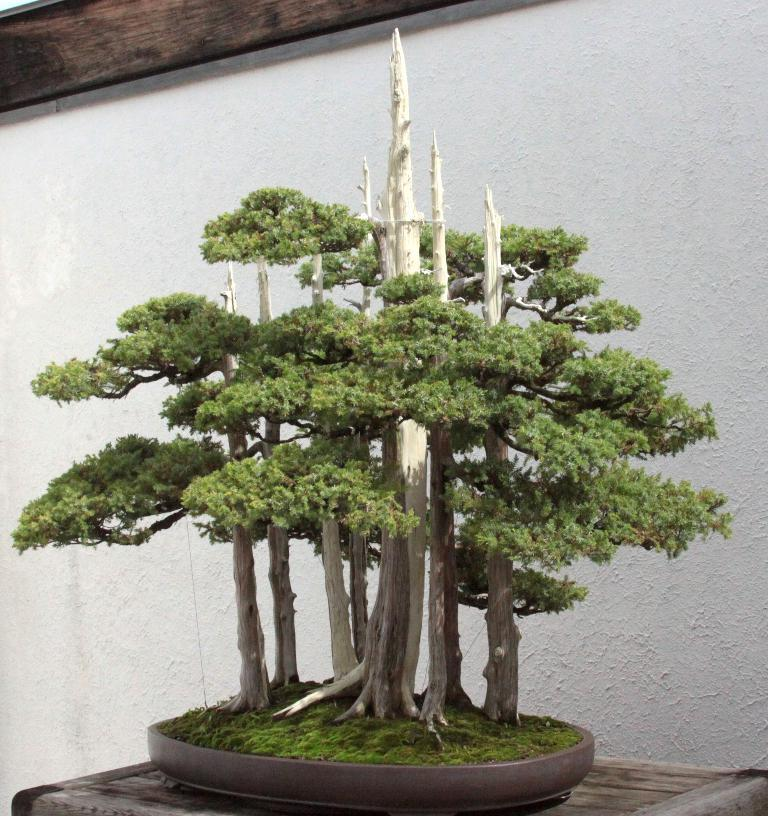What type of plant can be seen in the image? There is a tree in the image. What is the object on the surface of the image? The provided facts do not specify the object on the surface, so we cannot answer this question definitively. What is the color of the wall behind the tree? There is a white wall behind the tree. What is the appearance of the object truncated at the top of the image? The provided facts do not specify the appearance of the truncated object, so we cannot answer this question definitively. How many ladybugs are crawling on the tree in the image? There are no ladybugs present in the image; it only features a tree and a white wall. What advice does the brother in the image give to the person taking the photo? There is no brother present in the image, so we cannot answer this question. 